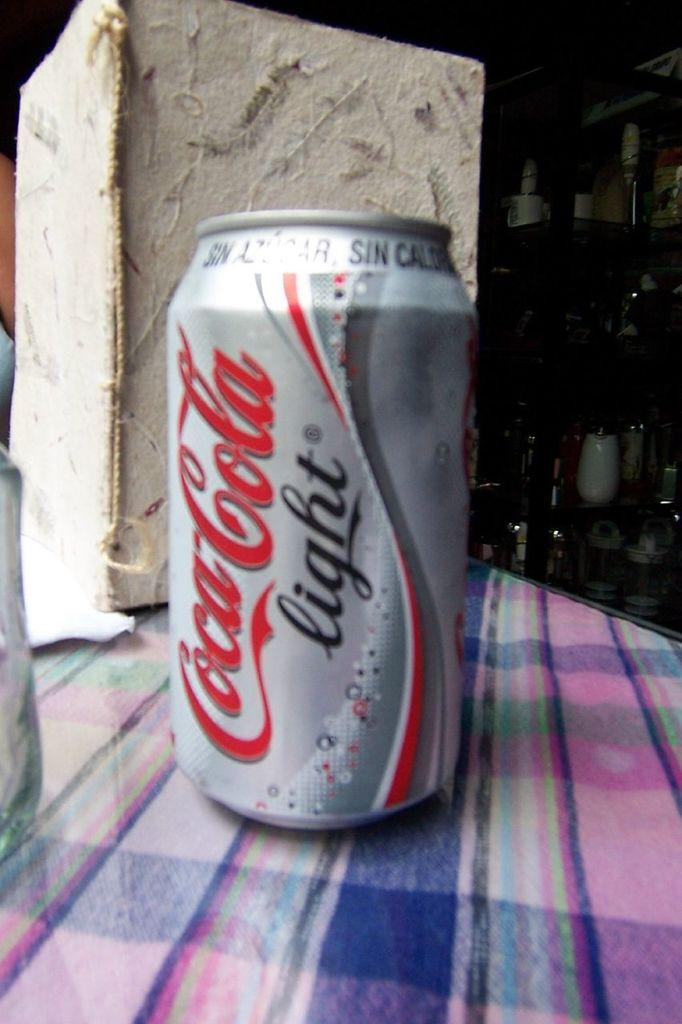Provide a one-sentence caption for the provided image. A silver, white and red can of coca cola light sitting on a plaid table cloth. 